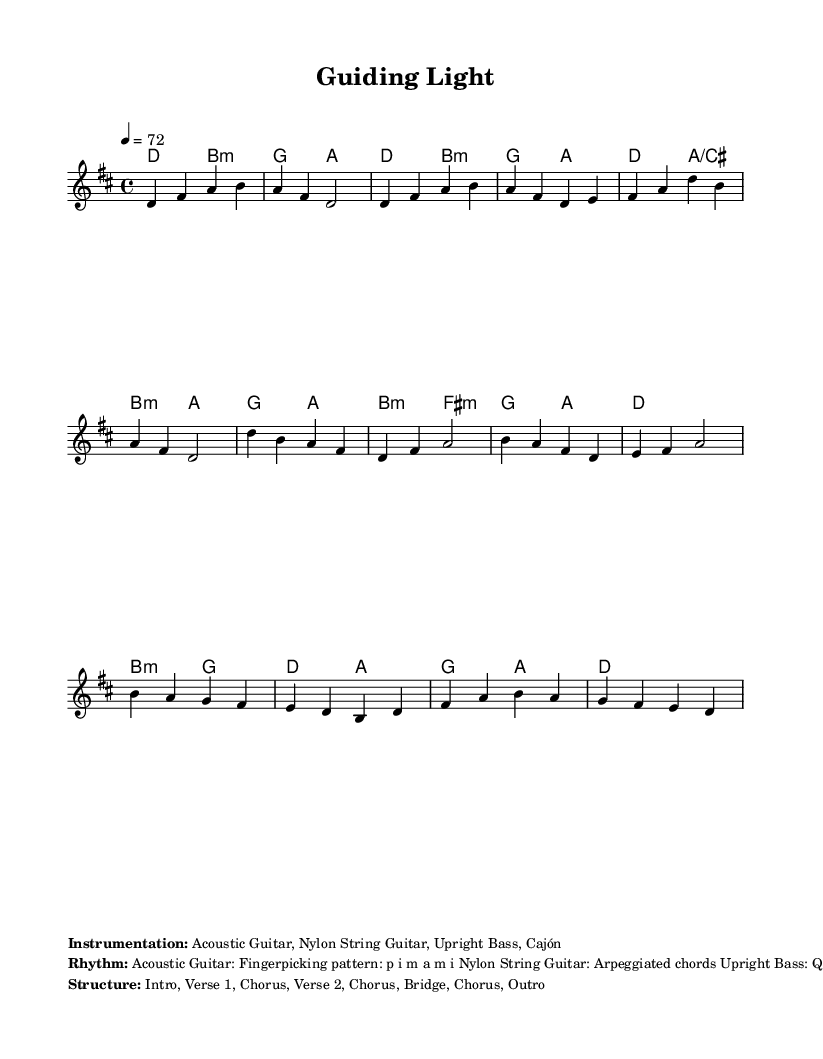What is the key signature of this music? The key signature indicates that there are two sharps (F# and C#) in this piece, which corresponds to D major.
Answer: D major What is the time signature of this piece? The time signature shown at the beginning of the score indicates that each measure contains four beats, and the quarter note gets one beat, which is represented as 4/4.
Answer: 4/4 What is the tempo marking for this piece? The tempo marking at the start specifies the speed at which the piece should be played, which is indicated as a quarter note equals seventy-two beats per minute.
Answer: 72 What type of rhythm is used by the acoustic guitar? In the additional instrumentation notes, it specifies that the acoustic guitar follows a fingerpicking pattern described by the sequence of the right-hand fingers for plucking the strings.
Answer: Fingerpicking How many sections does the song have? The structure of the song, provided in the sheet music, lists the distinct parts of the song and outlines that it contains eight sections: Intro, Verse 1, Chorus, Verse 2, Chorus, Bridge, Chorus, and Outro.
Answer: Eight What is the main theme explored in this ballad? The title of the sheet music "Guiding Light" and the themes of mentorship and personal growth suggest that the main idea revolves around support and personal development, which is characteristic of many mellow Latin ballads.
Answer: Mentorship and personal growth 